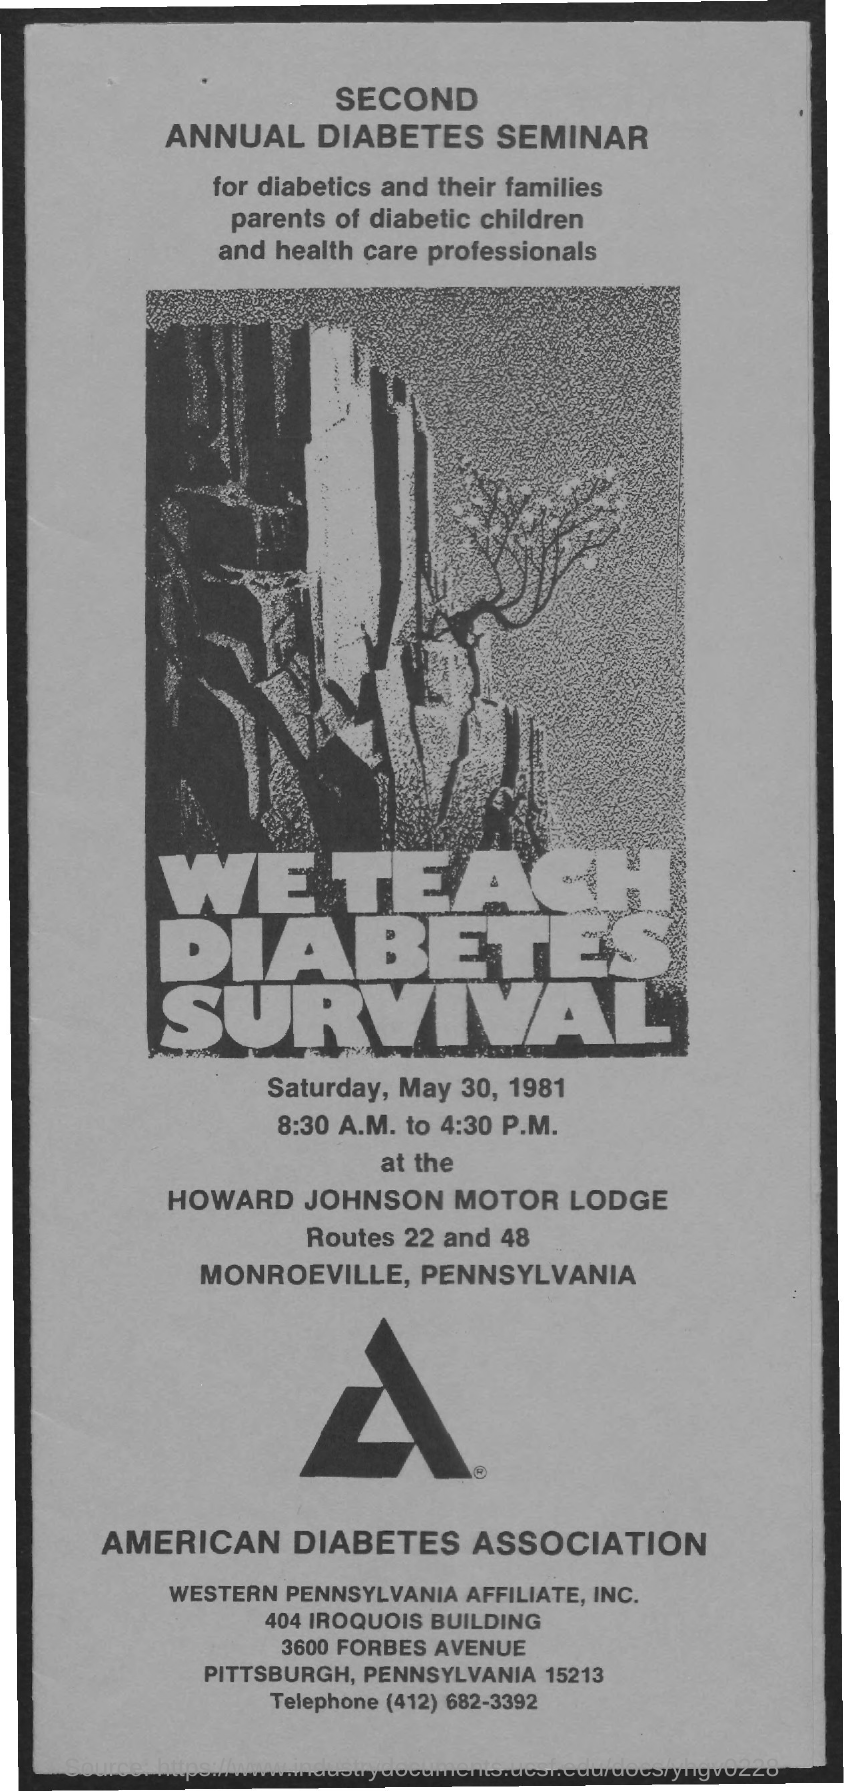Specify some key components in this picture. The seminar will be held on Saturday, May 30, 1981. Western Pennsylvania Affiliate, Inc. can be contacted through the telephone number (412) 682-3392. 